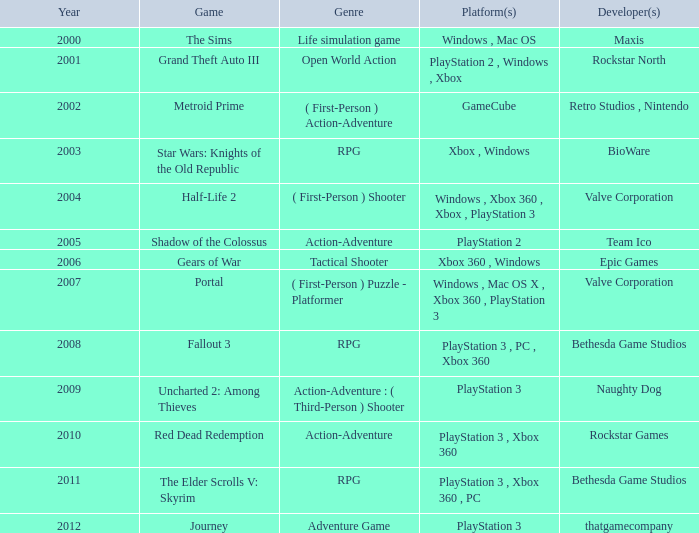Parse the full table. {'header': ['Year', 'Game', 'Genre', 'Platform(s)', 'Developer(s)'], 'rows': [['2000', 'The Sims', 'Life simulation game', 'Windows , Mac OS', 'Maxis'], ['2001', 'Grand Theft Auto III', 'Open World Action', 'PlayStation 2 , Windows , Xbox', 'Rockstar North'], ['2002', 'Metroid Prime', '( First-Person ) Action-Adventure', 'GameCube', 'Retro Studios , Nintendo'], ['2003', 'Star Wars: Knights of the Old Republic', 'RPG', 'Xbox , Windows', 'BioWare'], ['2004', 'Half-Life 2', '( First-Person ) Shooter', 'Windows , Xbox 360 , Xbox , PlayStation 3', 'Valve Corporation'], ['2005', 'Shadow of the Colossus', 'Action-Adventure', 'PlayStation 2', 'Team Ico'], ['2006', 'Gears of War', 'Tactical Shooter', 'Xbox 360 , Windows', 'Epic Games'], ['2007', 'Portal', '( First-Person ) Puzzle - Platformer', 'Windows , Mac OS X , Xbox 360 , PlayStation 3', 'Valve Corporation'], ['2008', 'Fallout 3', 'RPG', 'PlayStation 3 , PC , Xbox 360', 'Bethesda Game Studios'], ['2009', 'Uncharted 2: Among Thieves', 'Action-Adventure : ( Third-Person ) Shooter', 'PlayStation 3', 'Naughty Dog'], ['2010', 'Red Dead Redemption', 'Action-Adventure', 'PlayStation 3 , Xbox 360', 'Rockstar Games'], ['2011', 'The Elder Scrolls V: Skyrim', 'RPG', 'PlayStation 3 , Xbox 360 , PC', 'Bethesda Game Studios'], ['2012', 'Journey', 'Adventure Game', 'PlayStation 3', 'thatgamecompany']]} Before 2002, what genre did the sims belong to? Life simulation game. 